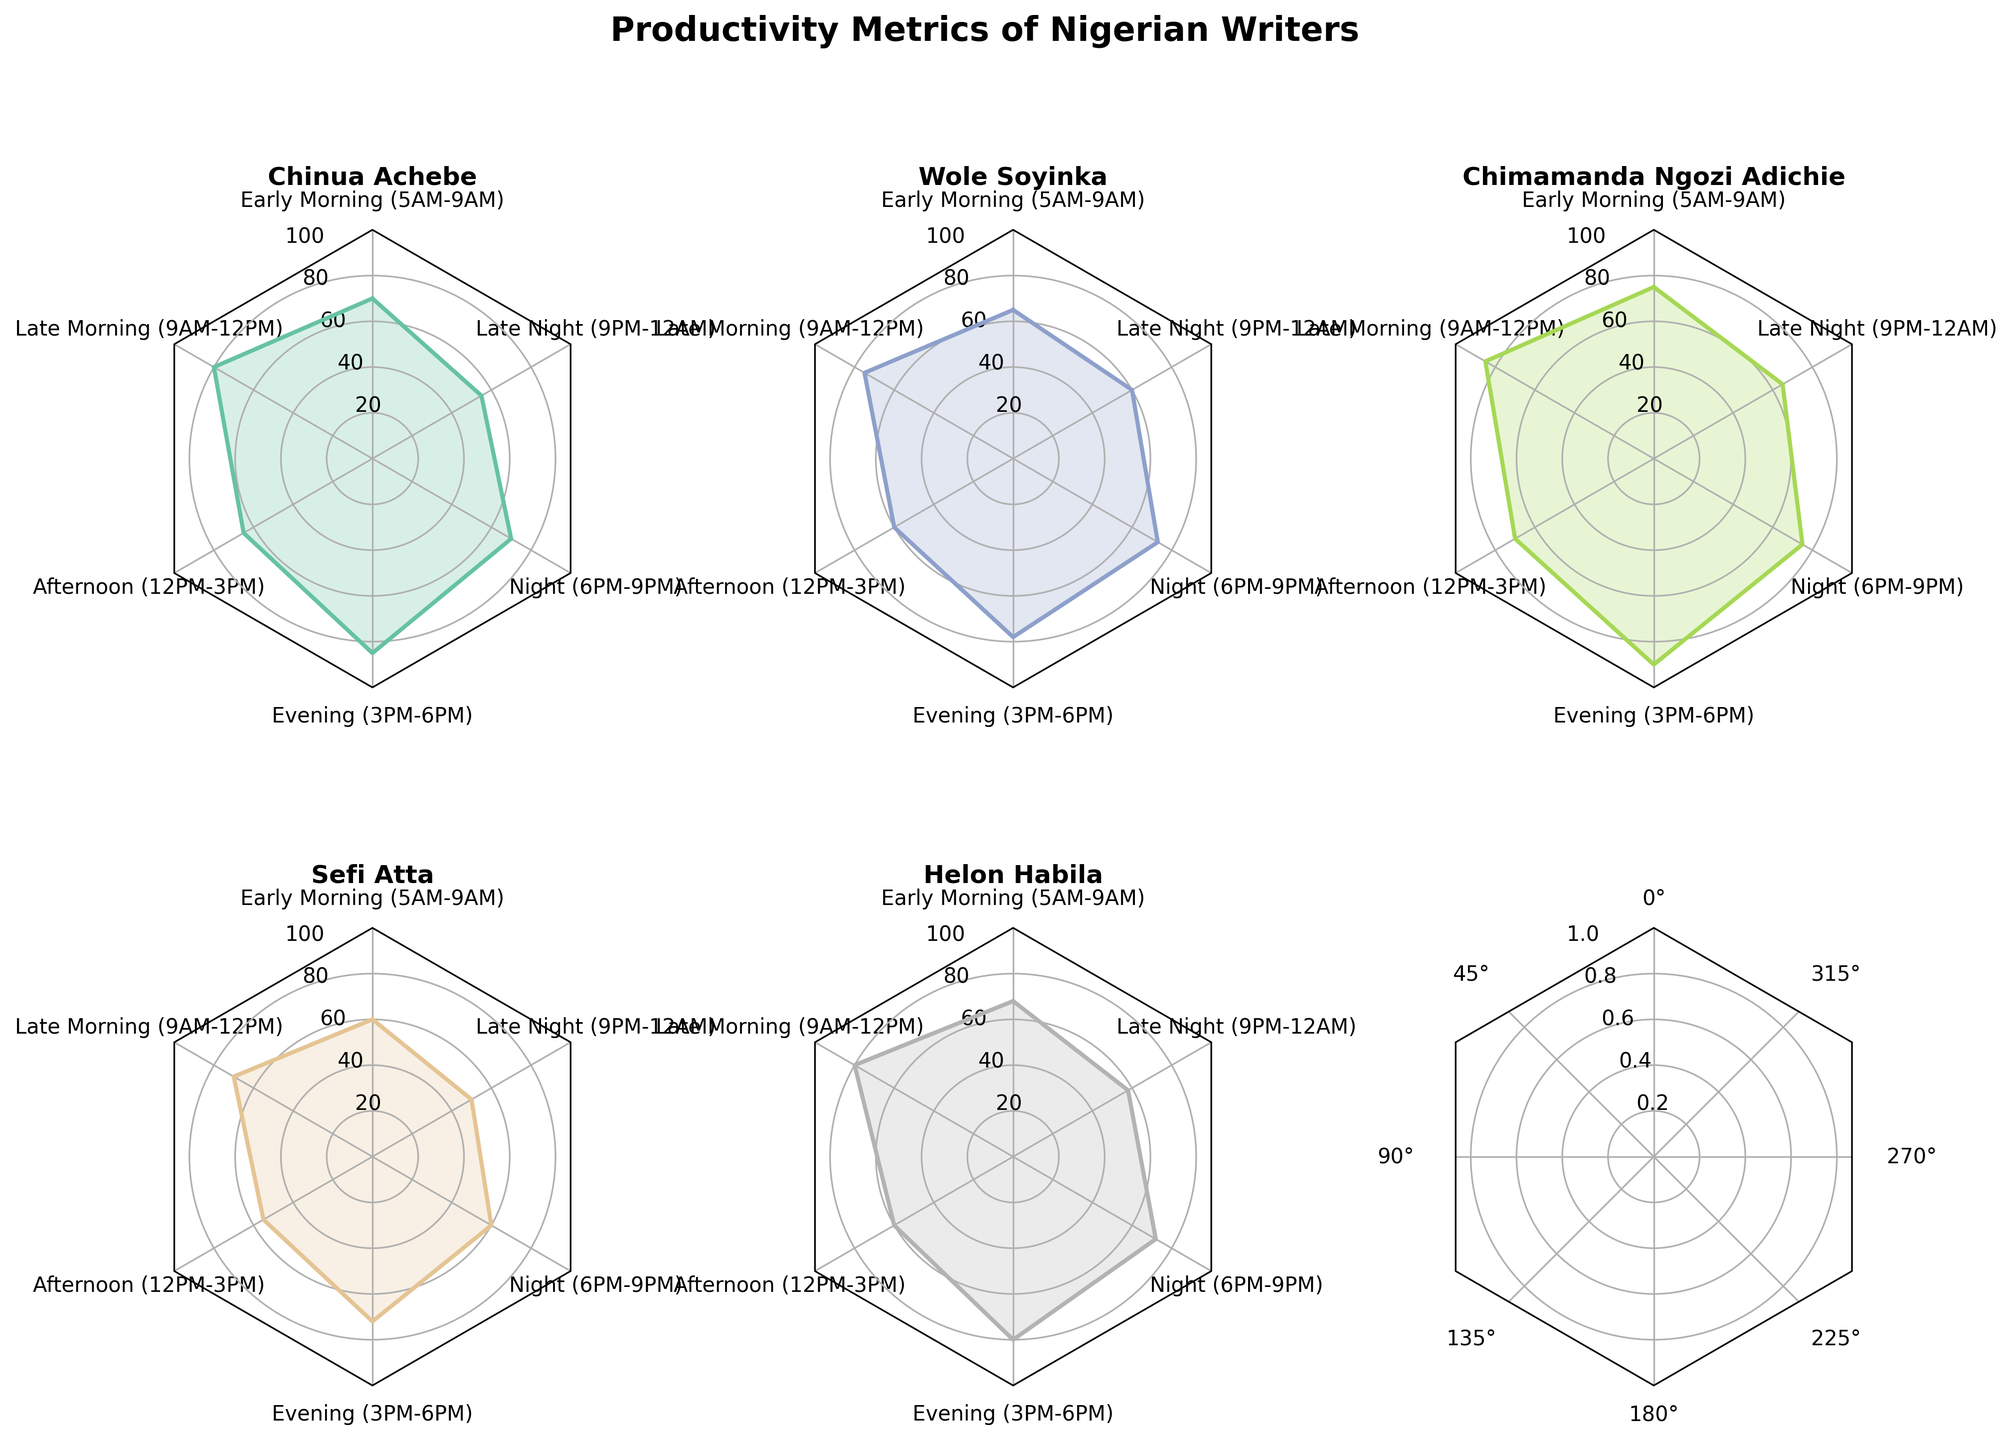What is the title of the figure? The title of the figure is prominently displayed at the top. It reads "Productivity Metrics of Nigerian Writers".
Answer: "Productivity Metrics of Nigerian Writers" How many different time periods are represented in each radar chart? Each radar chart has labels around its edge corresponding to different time periods. Counting these labels, there are six time periods.
Answer: Six Which writer has the highest productivity during the early morning (5AM-9AM)? Look at the values for each writer in the early morning section of their respective radar chart. Chinua Achebe has the highest value, which is 70.
Answer: Chinua Achebe What is the range of productivity values shown on the radar grids? The radar grids display productivity values at different intervals. From the grid lines, the range is from 0 to 100.
Answer: 0 to 100 For which time period does Chimamanda Ngozi Adichie have the highest productivity, and what is the value? On Chimamanda Ngozi Adichie's radar chart, identify which segment has the highest point. The highest point is during the evening (3PM-6PM) with a value of 90.
Answer: Evening (3PM-6PM), 90 Compare Wole Soyinka and Sefi Atta: Who has higher productivity in the afternoon (12PM-3PM)? On the radar charts, look for the values in the afternoon segment for both writers. Wole Soyinka has a value of 60, while Sefi Atta has a lower value of 55.
Answer: Wole Soyinka What is the average productivity value of Helon Habila across all time periods? Add up Helon Habila's values for each time segment and divide by the total number of segments: (68 + 80 + 60 + 80 + 72 + 58) / 6 = 69.67.
Answer: 69.67 Which writer shows the most variation in productivity across different times of the day? By observing the radar charts, identify the writer whose chart has the most fluctuation in values. Chimamanda Ngozi Adichie's chart shows significant peaks and valleys, indicating high variation.
Answer: Chimamanda Ngozi Adichie In the late night (9PM-12AM), who has the lowest productivity and what is the value? Look at the late night segment for all radar charts. Sefi Atta has the lowest value of 50.
Answer: Sefi Atta, 50 